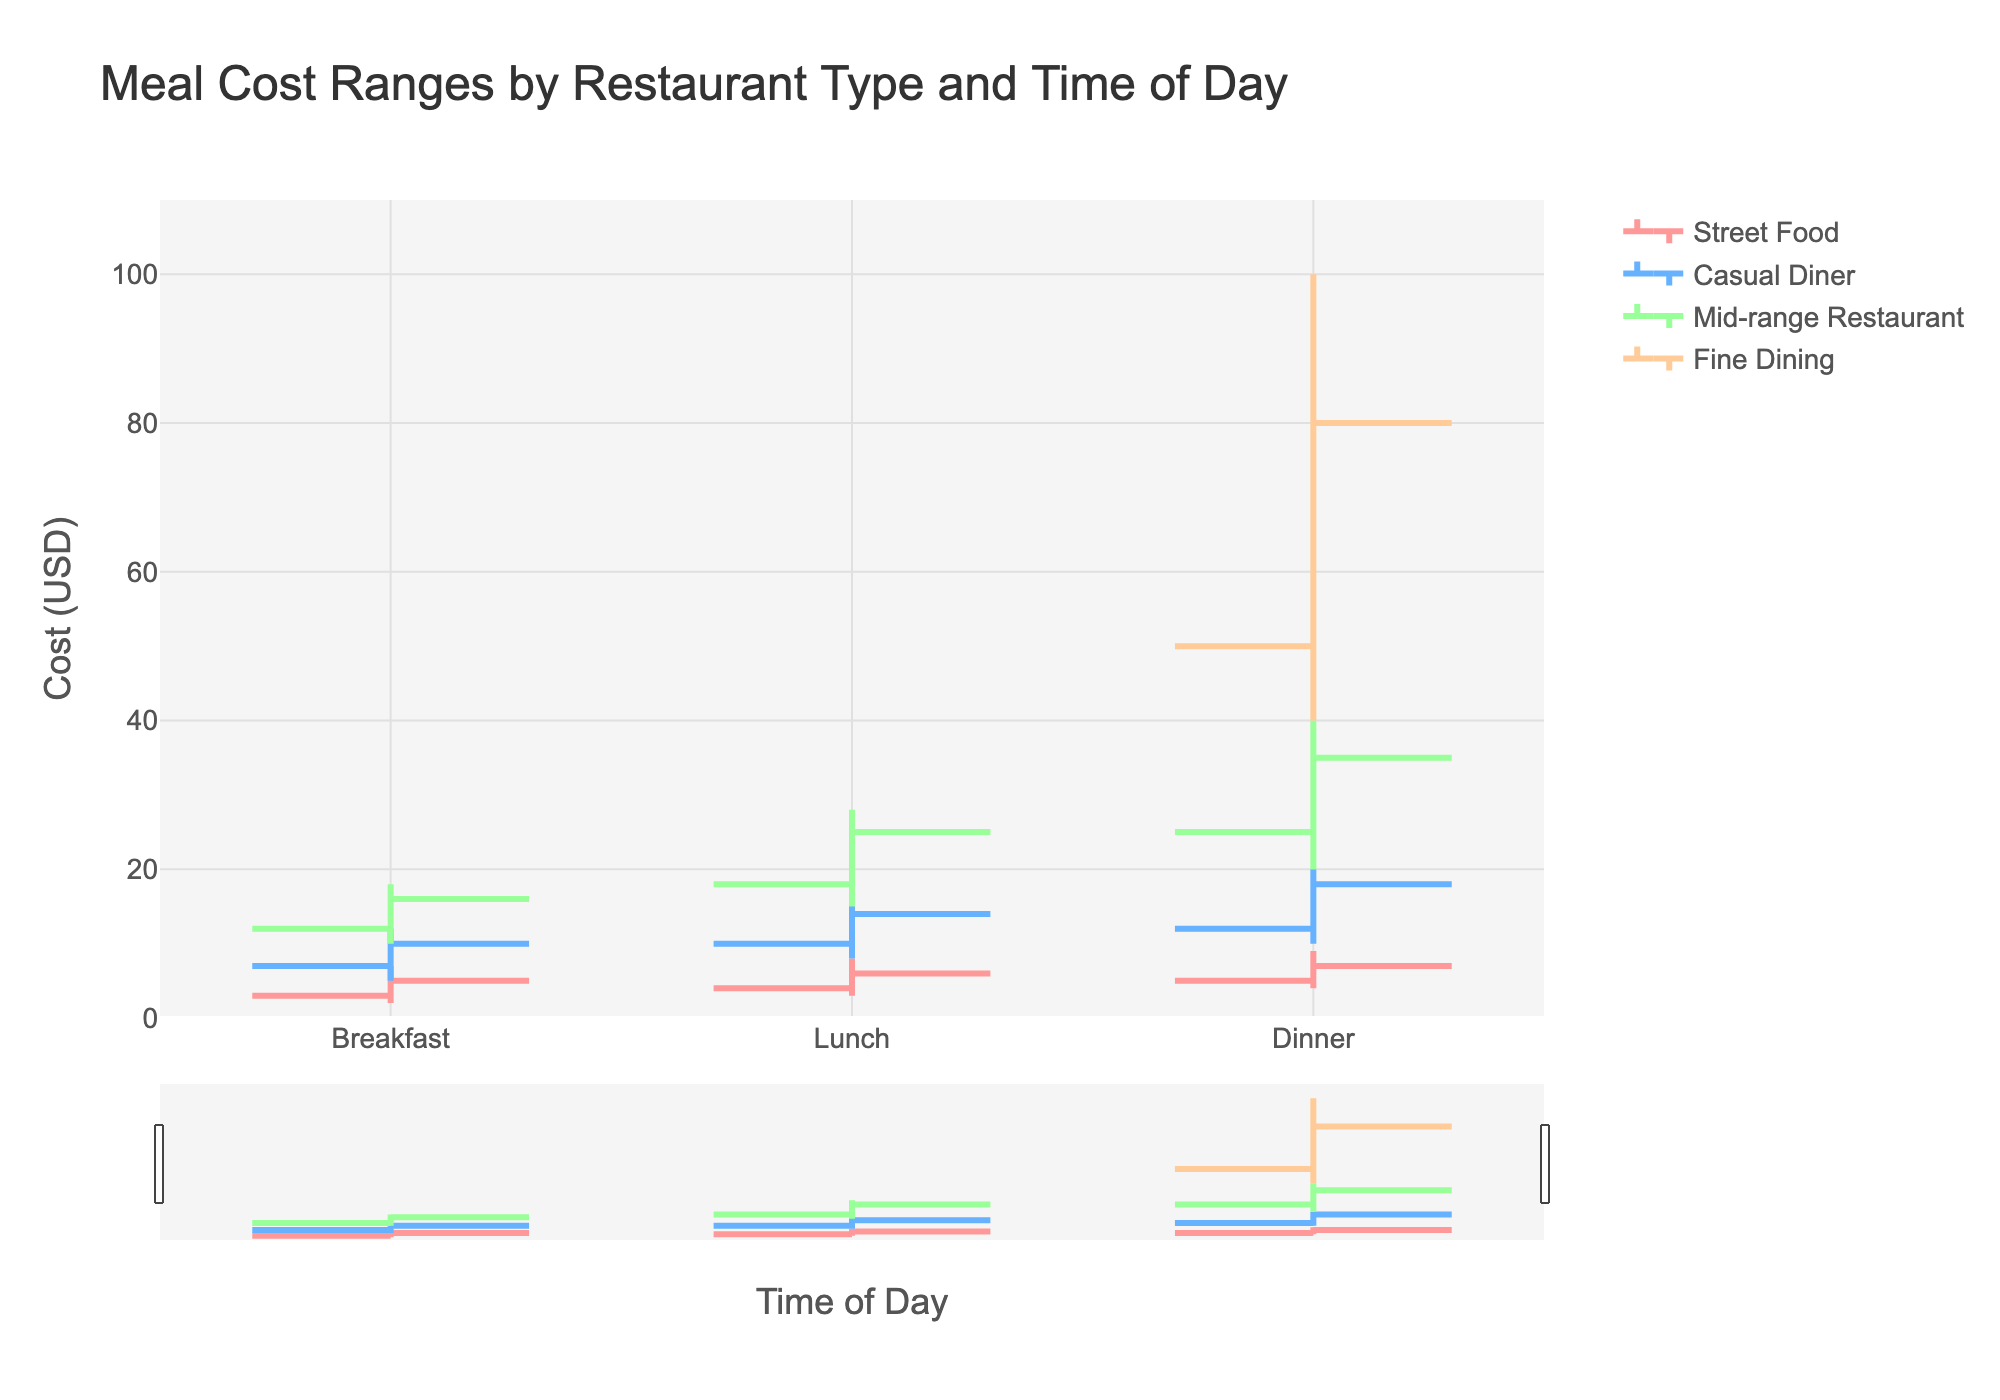What is the title of the figure? The title of the figure is typically located at the top center of the chart and provides a brief description of what the chart represents. In this case, it is "Meal Cost Ranges by Restaurant Type and Time of Day"
Answer: Meal Cost Ranges by Restaurant Type and Time of Day How many time slots are shown for Street Food? By counting the number of distinct time periods shown on the x-axis for the Street Food category, we see that there are three: Breakfast, Lunch, and Dinner
Answer: Three What is the cost range for a Casual Diner during lunch? To determine the cost range, identify the low and high values for the Casual Diner during lunch. The low value is 8 and the high value is 16. Therefore, the cost range is 8 to 16 USD
Answer: 8 to 16 USD Which restaurant type has the highest meal cost for dinner? We need to look at the dinner data points and compare the high values. The Fine Dining category has the highest value at 100 USD
Answer: Fine Dining What is the closing cost value for Street Food during breakfast? The closing cost value is identified by the 'close' column for Street Food during breakfast, which is 5 USD
Answer: 5 USD Which type of restaurant shows the greatest cost range for any meal? To find this, calculate the cost range for each time slot across all restaurants. The Fine Dining Dinner range is the greatest, from 40 to 100 USD, giving a range of 60 USD
Answer: Fine Dining Dinner What is the difference between the high and low costs for Mid-range Restaurant during lunch? Subtract the low value from the high value for the Mid-range Restaurant during lunch. The calculation is 28 - 15 = 13 USD
Answer: 13 USD How does the cost range for breakfast compare between Street Food and Casual Diner? Compare the high and low values for both categories. Street Food ranges from 2 to 7 USD, and Casual Diner ranges from 5 to 12 USD. The range for Casual Diner is higher in both the lower and higher ends
Answer: Casual Diner has a higher range What is the average of the closing costs for all dinner categories? Sum the closing costs for dinner across all categories and divide by the number of categories: (7 + 18 + 35 + 80) / 4 = 35 USD
Answer: 35 USD What colors are used to represent the different restaurant types in the figure? Each restaurant type is represented by a unique color, typically found in figure legends. The colors used are not explicitly defined here but are shades including red, blue, green, and orange to distinguish categories
Answer: Shades of red, blue, green, and orange 